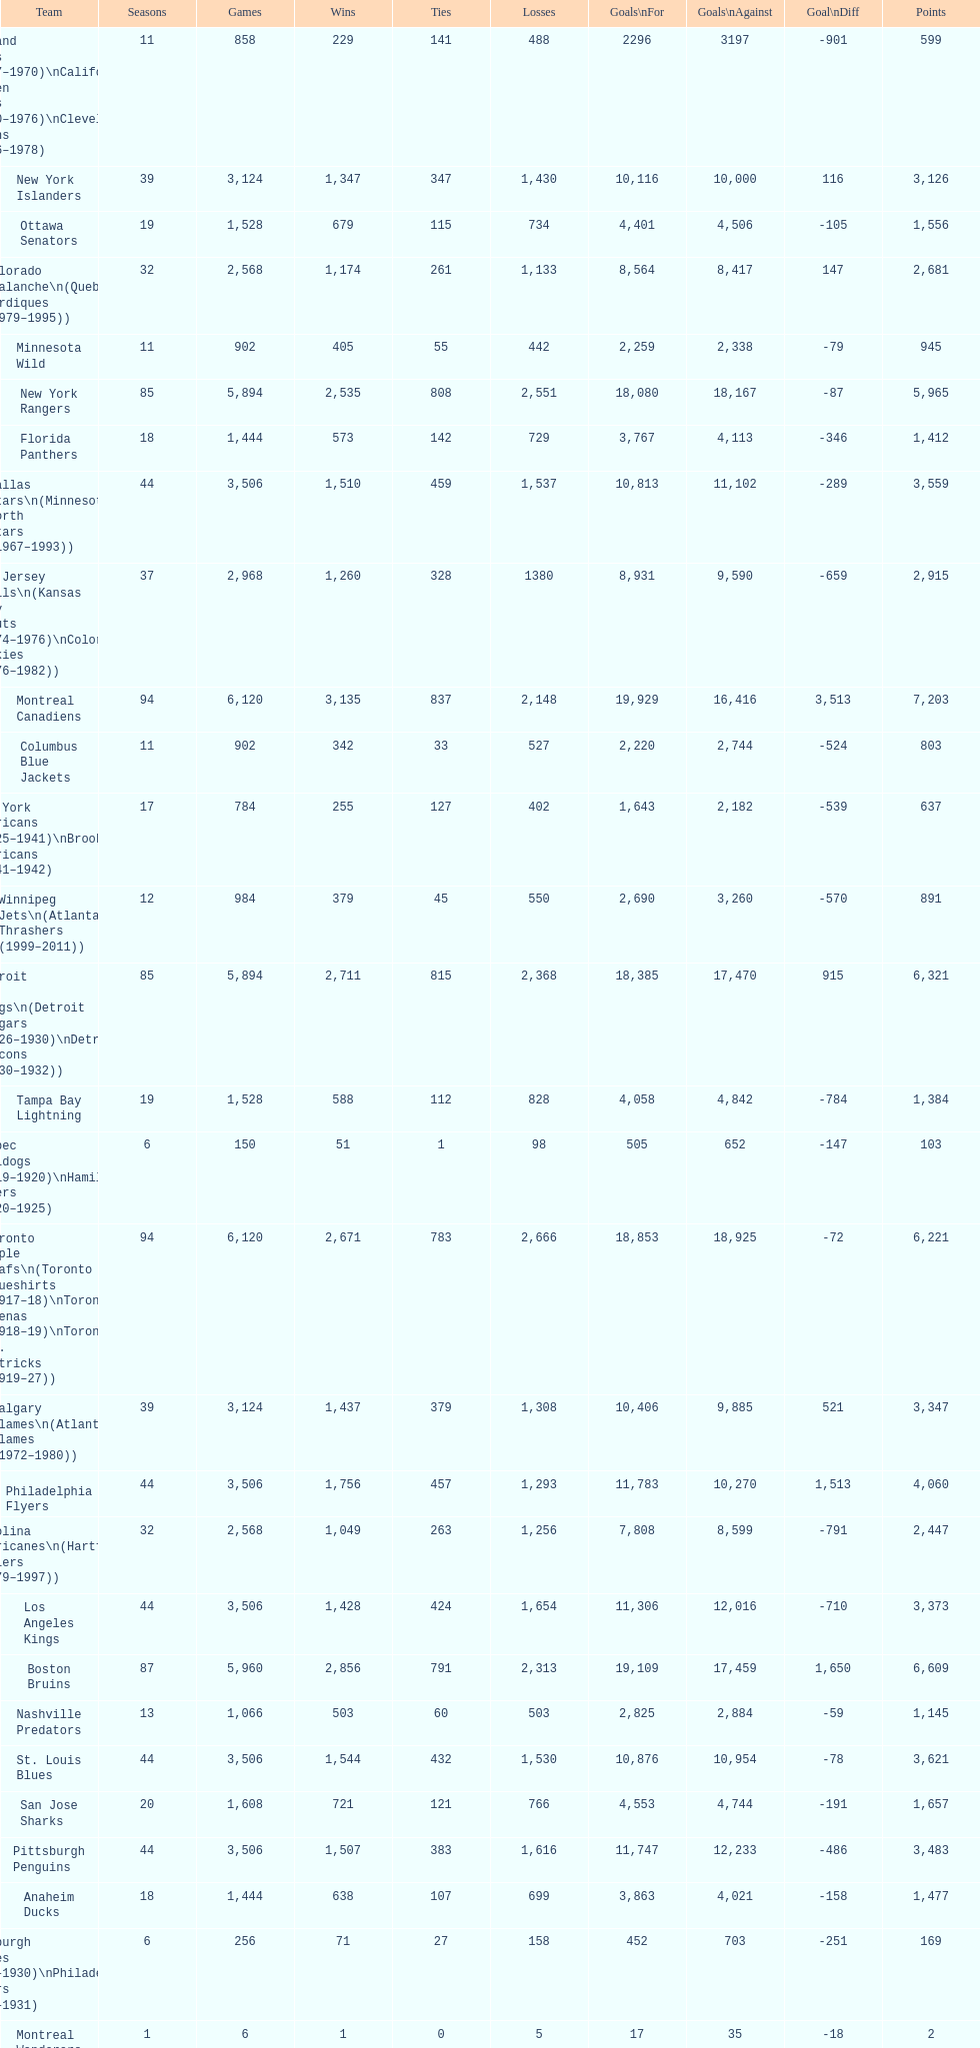What is the quantity of games that the vancouver canucks have triumphed in up to this moment? 1,353. 